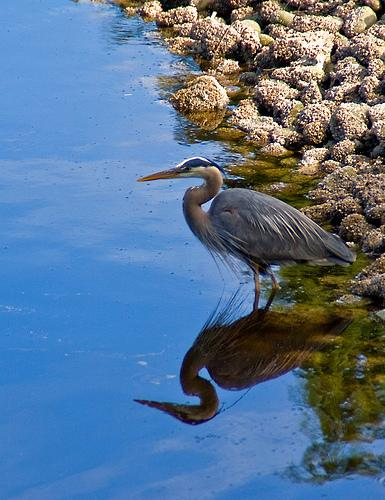Write a short statement about the primary focus of the image and its notable features. A bird with a curved neck, long orange beak, and grey-blue body stands in water near brown rocks and moss-covered formations. Mention the primary object in the image and its action. A large aquatic bird with a long neck and orange beak is wading out into a lake. Briefly describe the central object and the situation it is involved in. A bird with an orange beak and dark grey tail is standing in water near a rocky shore, as its reflection can be seen on the water's surface. Briefly describe the main object and its location in the image. A pelican with a long beak and blue head standing on shore near rocks and water. Provide a succinct description of the principal element in the image and its surroundings. A bird with an orange beak and grey-blue body beside brown rocks and algae-covered rocks, standing in blue water. Identify the key subject in the image and describe its appearance. A bird with an orange beak, dark blue stripes on its head, and a long curved neck looking at the water near a rocky shore. Express the main idea of the image and the actions taking place. A crane wading in water, its long orange beak and thin feathers on chest visible, with the reflection of its head and neck in the water. Write a concise description of the central focus of the image. A crane with long feathers and an orange beak stands near a waterbody, with its reflection visible in the water. What is the main subject of the image and a few of its significant characteristics? A large bird with an orange beak, grey and blue body, and long feathers on its chest is wading in water near a group of rocks and algae. What's the most prominent element in the image and its features? A blue and white bird with dark blue stripes on its head, a long orange beak, and thin feathers on its chest. 